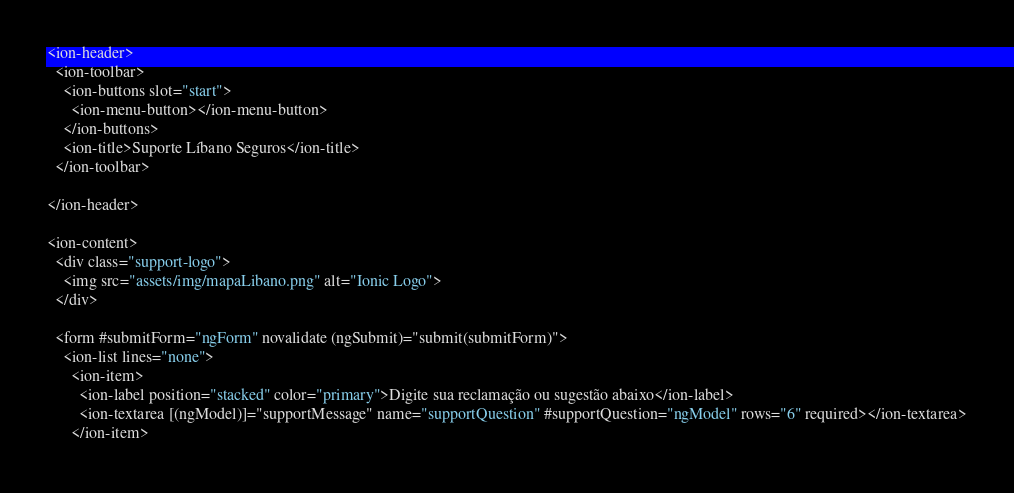<code> <loc_0><loc_0><loc_500><loc_500><_HTML_><ion-header>
  <ion-toolbar>
    <ion-buttons slot="start">
      <ion-menu-button></ion-menu-button>
    </ion-buttons>
    <ion-title>Suporte Líbano Seguros</ion-title>
  </ion-toolbar>

</ion-header>

<ion-content>
  <div class="support-logo">
    <img src="assets/img/mapaLibano.png" alt="Ionic Logo">
  </div>

  <form #submitForm="ngForm" novalidate (ngSubmit)="submit(submitForm)">
    <ion-list lines="none">
      <ion-item>
        <ion-label position="stacked" color="primary">Digite sua reclamação ou sugestão abaixo</ion-label>
        <ion-textarea [(ngModel)]="supportMessage" name="supportQuestion" #supportQuestion="ngModel" rows="6" required></ion-textarea>
      </ion-item></code> 